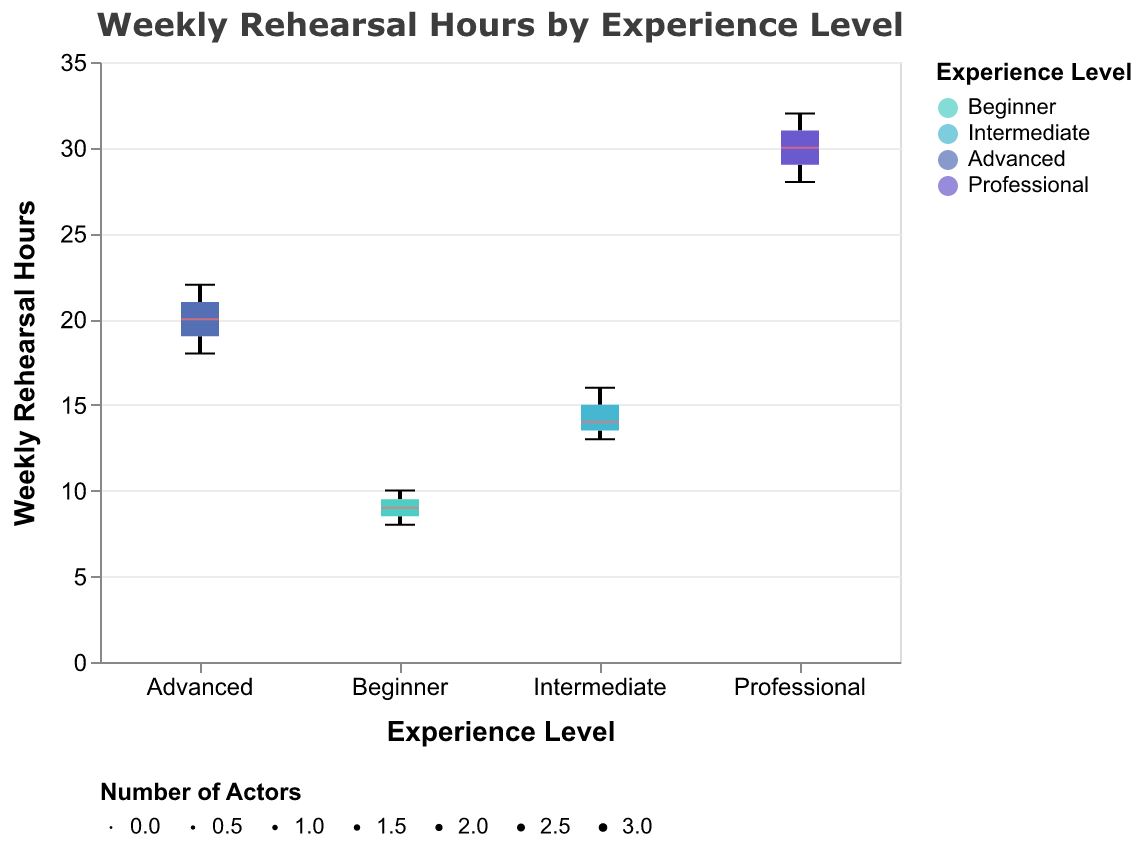What does the title of the chart say? The title of the chart is clearly displayed at the top. It reads "Weekly Rehearsal Hours by Experience Level."
Answer: Weekly Rehearsal Hours by Experience Level Which experience level group has the highest median weekly rehearsal hours? To determine the group with the highest median, observe the line inside the boxes representing each experience level. The 'Professional' group displays the highest median weekly rehearsal hours.
Answer: Professional What's the range of weekly rehearsal hours for the Intermediate group? The range is identified by the minimum and maximum values of the whiskers for the Intermediate group. This group rehearses between 13 and 16 hours weekly.
Answer: 13 to 16 hours How many actors are there in the Advanced group? The width of the box plot represents the number of data points. The Advanced group has a wide box, indicating three actors.
Answer: 3 Which experience level group has the smallest interquartile range (IQR) in weekly rehearsal hours? The IQR is the range between the first quartile and the third quartile. The box length represents this range, and the Intermediate group's box is the smallest.
Answer: Intermediate What's the difference in median weekly rehearsal hours between the Beginner and Advanced groups? The median for the Beginner group is 9, and for the Advanced group, it's 20. The difference is calculated by subtracting 9 from 20.
Answer: 11 hours Compare the maximum weekly rehearsal hours of the Beginner group to those of the Professional group. The maximum rehearsal hours for the Beginner group are 10, and for the Professional group, it is 32.
Answer: 32 is greater than 10 Which experience level has the widest range of weekly rehearsal hours? The range is the difference between the minimum and maximum whisker values. The Professional group spans from 28 to 32 hours, which is the widest range.
Answer: Professional What color represents the Intermediate group in the chart? Each experience level is designated a different color for easy identification. The Intermediate group is represented by a blue color.
Answer: Blue 